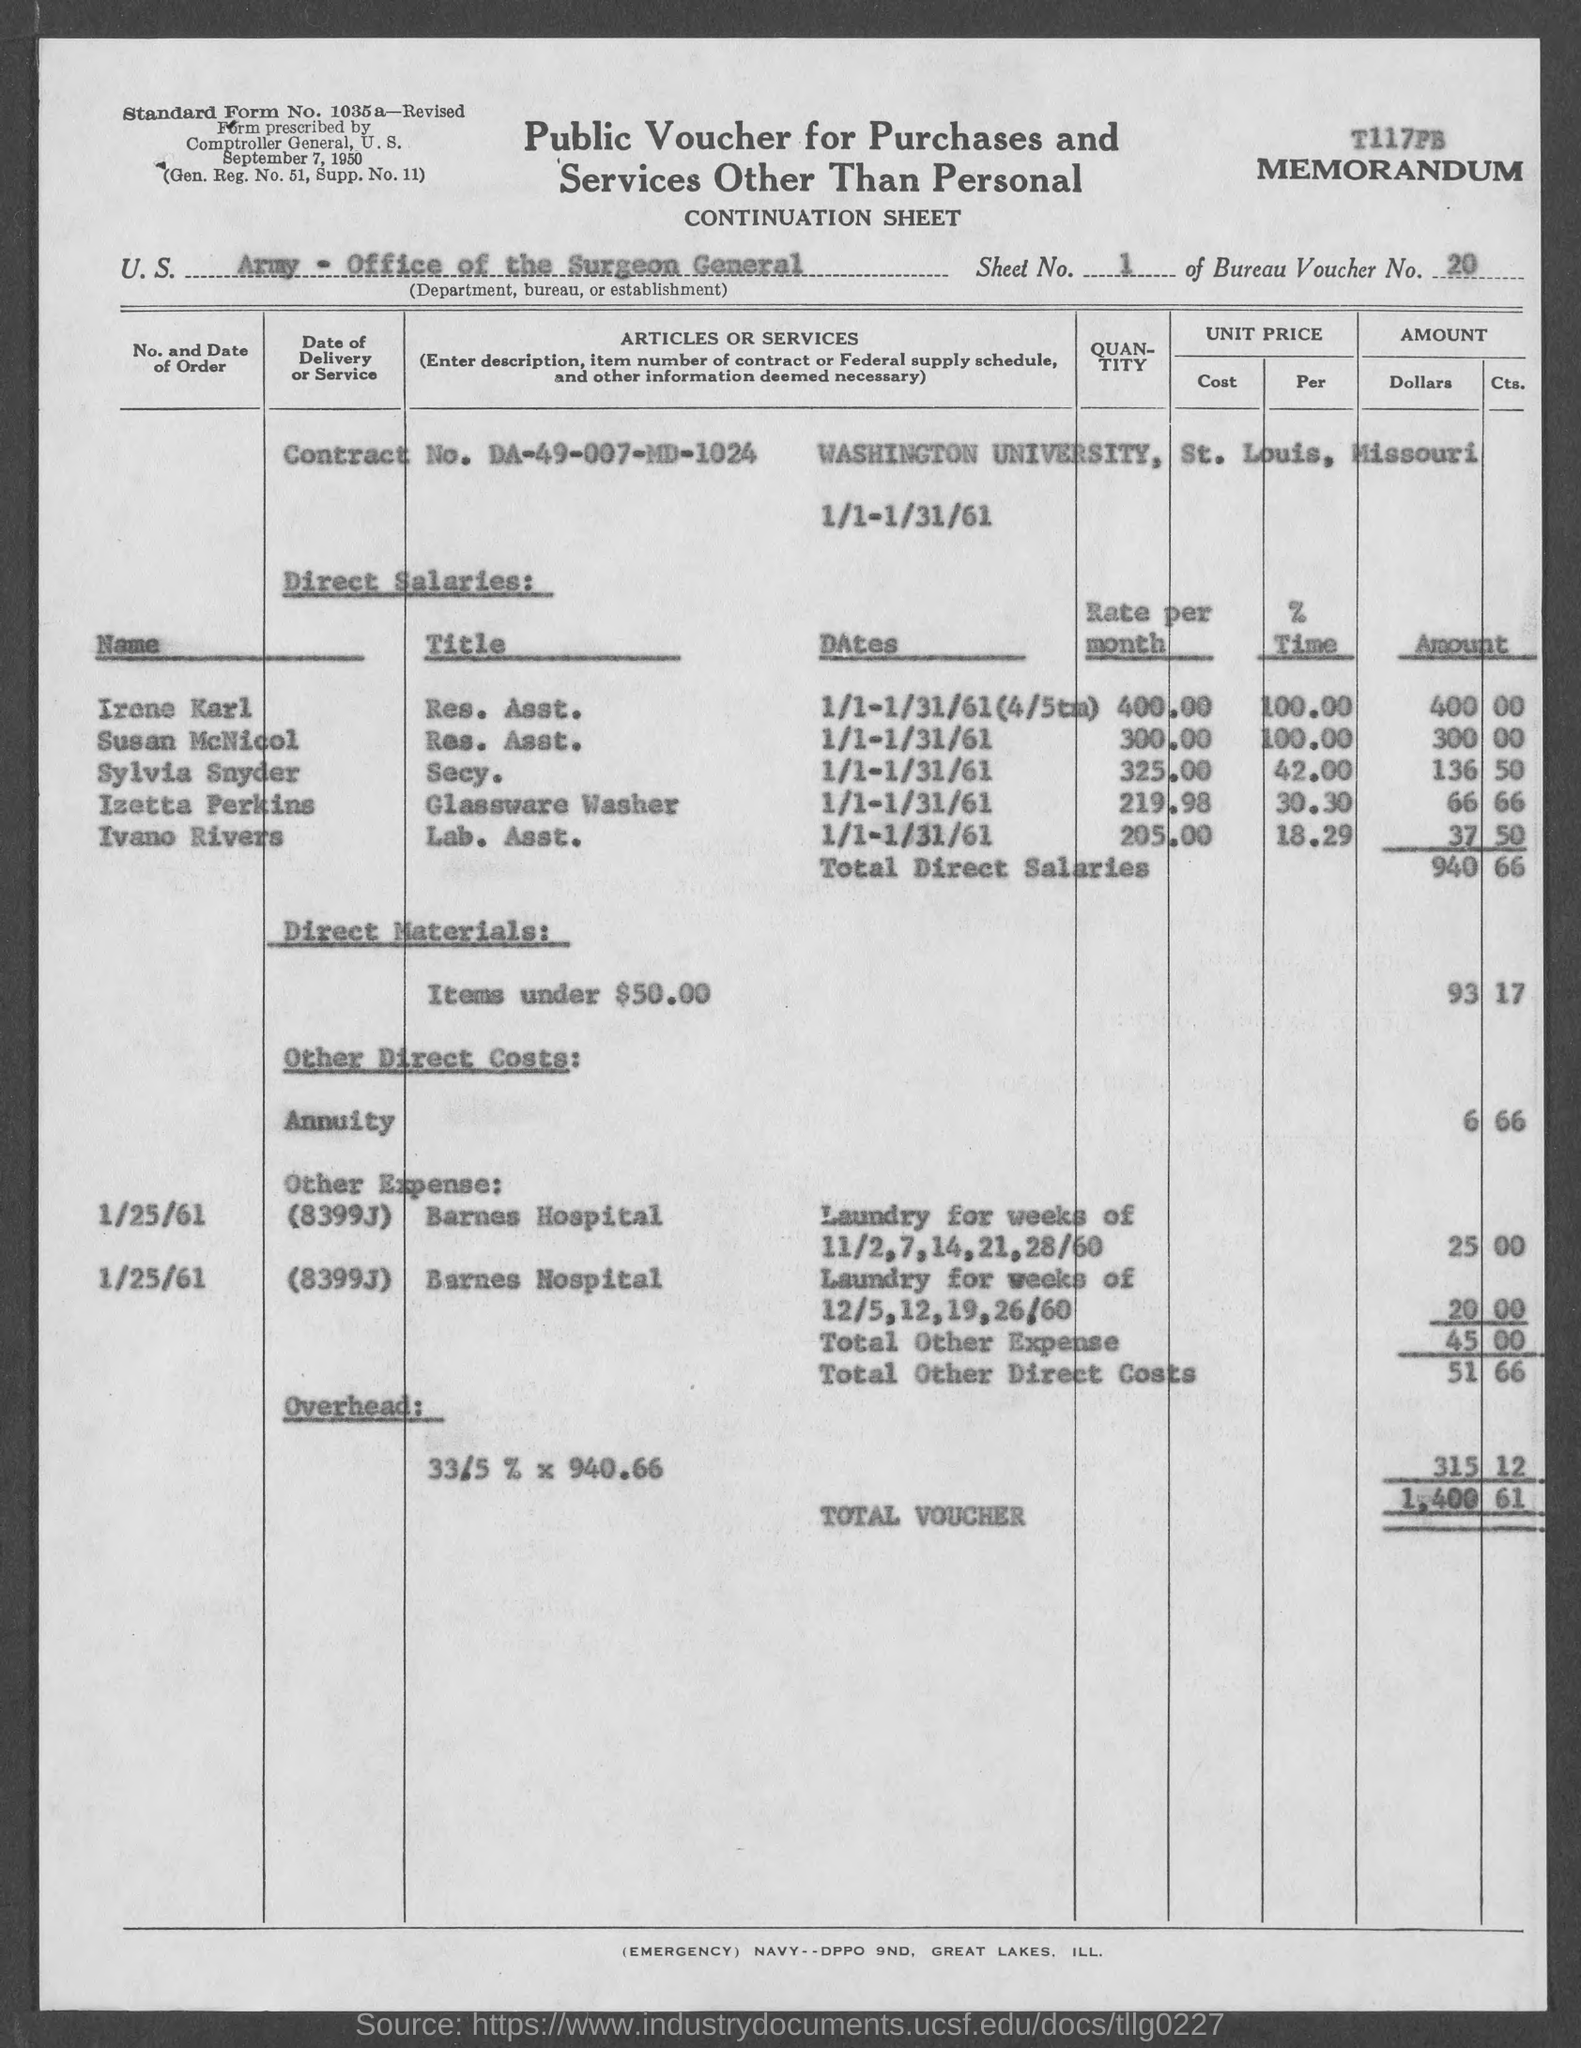What is the Bureau Voucher No. given in the Memorandum ?
Your answer should be very brief. 20. What is the contract no. given in the memorandum ?
Make the answer very short. DA-49-007-MD-1024. Which university is mentioned in the memorandum ?
Your answer should be compact. Washington university. What is the rate per month of Irena Karl ?
Provide a succinct answer. 400.00. What is the total amount mentioned against the "total voucher" ?
Your answer should be compact. 1,400-61. Which hospital is mentioned under the "other expenses" ?
Make the answer very short. Barnes hospital. 